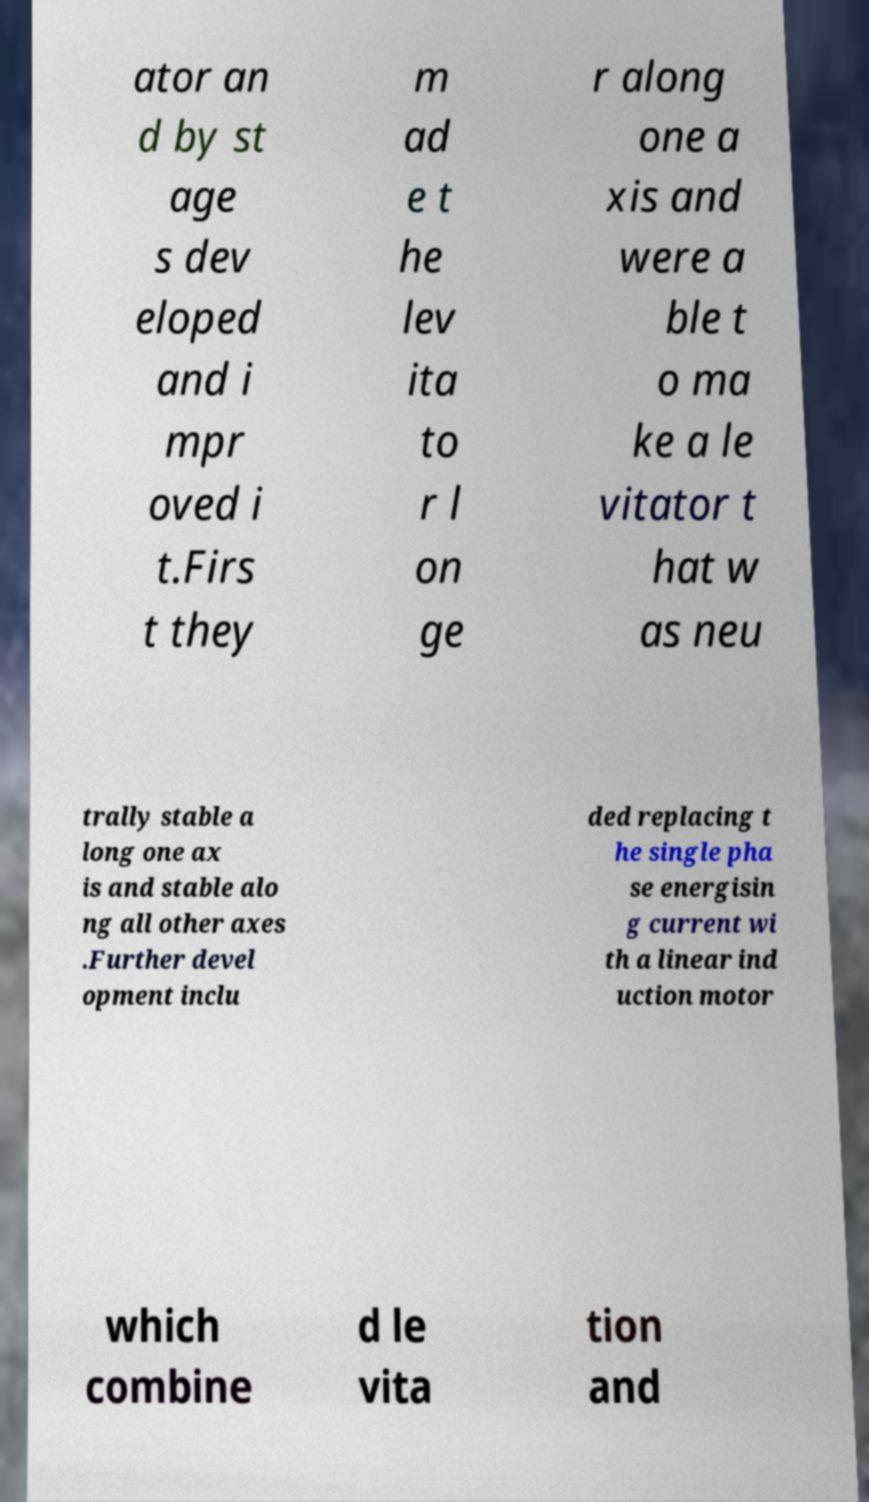There's text embedded in this image that I need extracted. Can you transcribe it verbatim? ator an d by st age s dev eloped and i mpr oved i t.Firs t they m ad e t he lev ita to r l on ge r along one a xis and were a ble t o ma ke a le vitator t hat w as neu trally stable a long one ax is and stable alo ng all other axes .Further devel opment inclu ded replacing t he single pha se energisin g current wi th a linear ind uction motor which combine d le vita tion and 